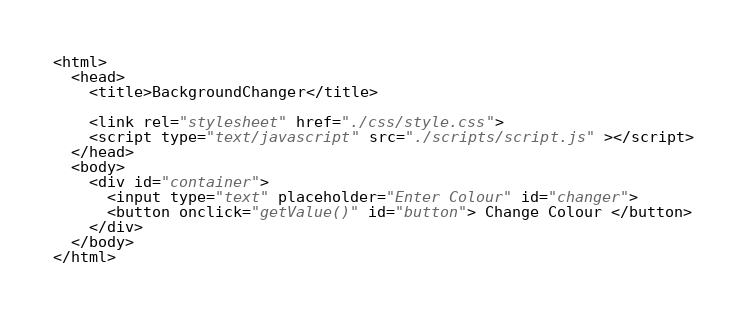<code> <loc_0><loc_0><loc_500><loc_500><_HTML_><html>
  <head>
    <title>BackgroundChanger</title>

    <link rel="stylesheet" href="./css/style.css">
    <script type="text/javascript" src="./scripts/script.js" ></script>
  </head>
  <body>
    <div id="container">
      <input type="text" placeholder="Enter Colour" id="changer">
      <button onclick="getValue()" id="button"> Change Colour </button>
    </div>
  </body>
</html>
</code> 